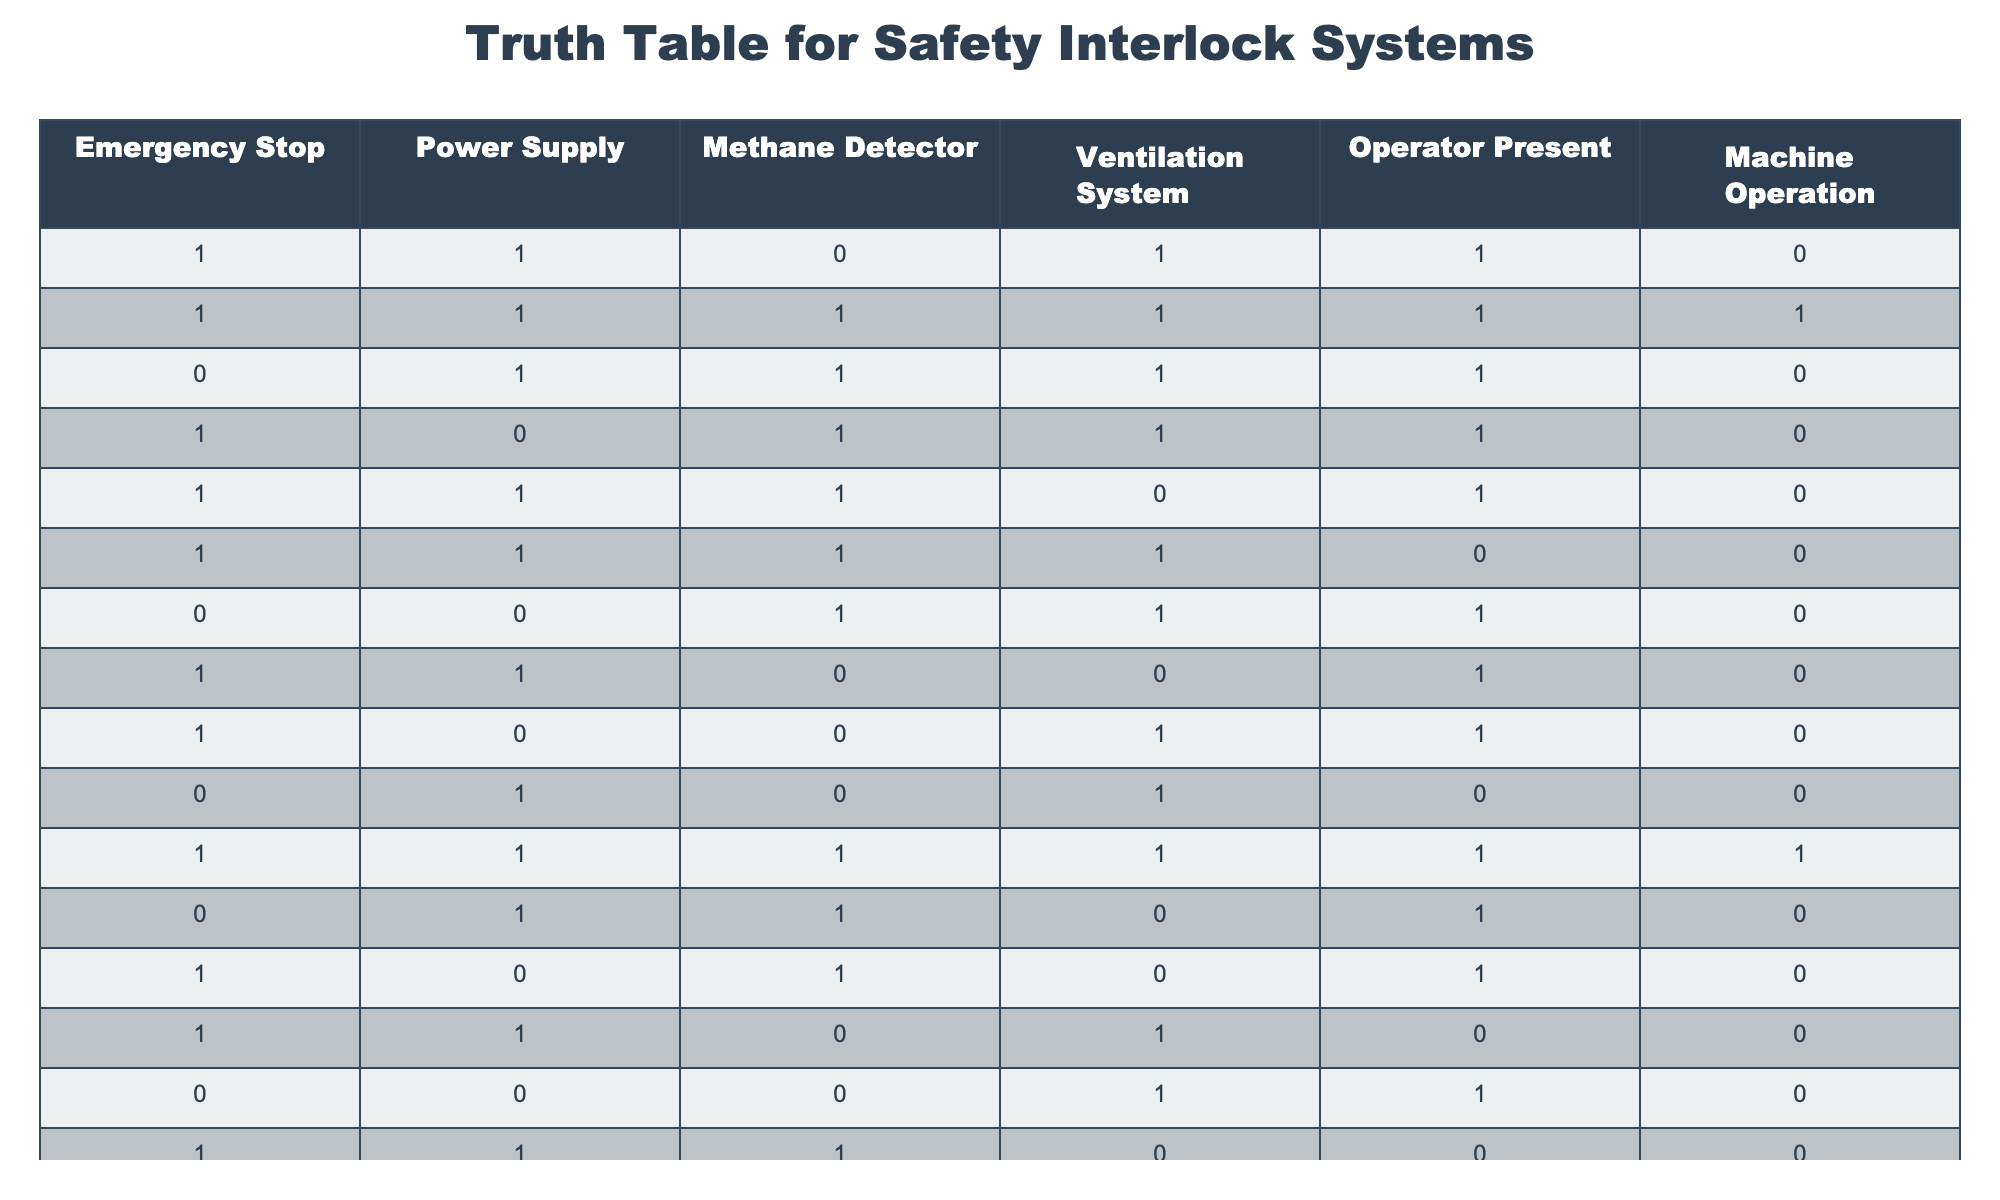What is the value of "Machine Operation" when "Emergency Stop" is 1 and "Power Supply" is 1? Looking at the table, there are multiple rows where both "Emergency Stop" and "Power Supply" are 1. The values for "Machine Operation" in these cases are found in rows 1, 2, 4, 5, 6, 8, 10, and 11. Among these, the values for "Machine Operation" are 0, 1, 0, 0, 0, 0, 0, and 1 respectively. The value of interest is therefore 0 or 1, depending on the specific criteria used.
Answer: 0 or 1 How many times does the "Methane Detector" have a value of 1 while "Machine Operation" is also 1? From the table, we can filter for rows where "Methane Detector" is 1 and then count how many of these have "Machine Operation" as 1. The relevant rows to consider are 2 and 11. So, the total is 2.
Answer: 2 Is there a scenario where the "Power Supply" is 0 and "Machine Operation" is 1? Reviewing the table, we find the only scenario where "Power Supply" is 0 corresponds to rows 4, 8, 13, 14, and 15. In all of these cases, "Machine Operation" is 0, thus confirming that there are no instances where this scenario exists.
Answer: No How many total scenarios are there with "Operator Present" equal to 0 and "Machine Operation" equal to 0? We can filter rows where "Operator Present" is 0 (specifically rows 5, 6, 12, 14, and 15) and then check the "Machine Operation" values in these rows. All are 0. Hence, we count a total of 5 scenarios.
Answer: 5 What percentage of all scenarios results in "Machine Operation" equal to 1? There are 15 total scenarios in the table. The count of rows where "Machine Operation" is 1 are rows 2 and 11, resulting in 2 total successes. To find the percentage, we calculate (2/15) * 100, which is approximately 13.33%.
Answer: 13.33% 